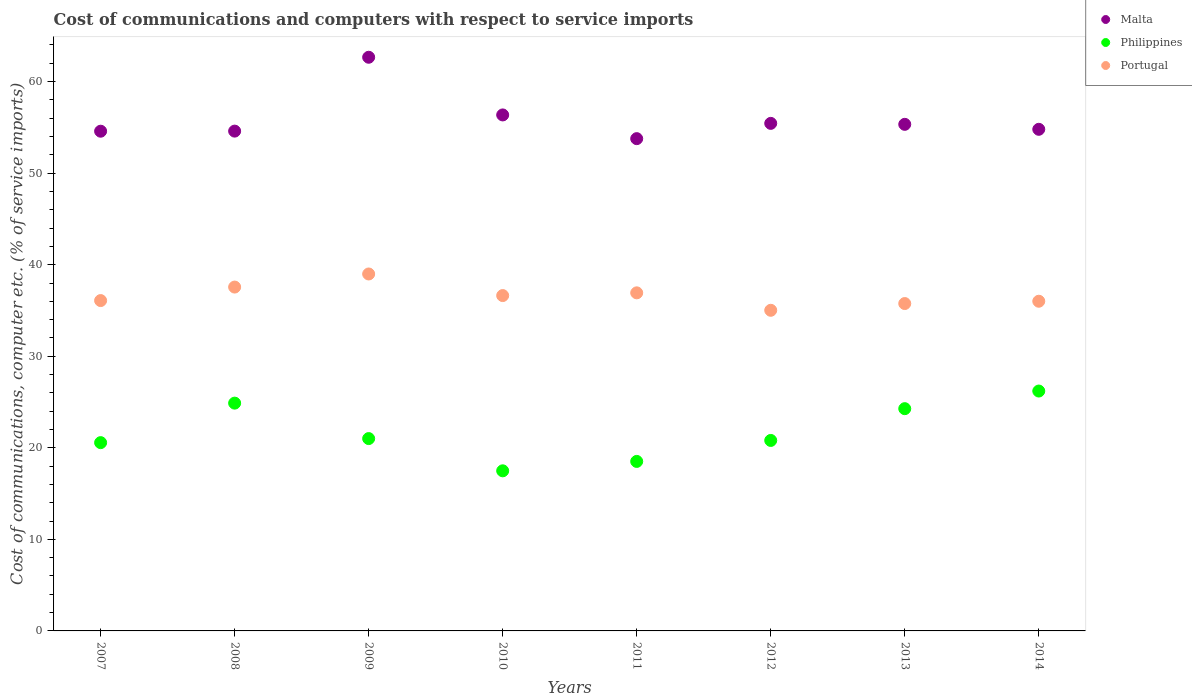What is the cost of communications and computers in Malta in 2011?
Ensure brevity in your answer.  53.77. Across all years, what is the maximum cost of communications and computers in Philippines?
Your answer should be compact. 26.2. Across all years, what is the minimum cost of communications and computers in Portugal?
Provide a short and direct response. 35.02. What is the total cost of communications and computers in Portugal in the graph?
Provide a succinct answer. 292.98. What is the difference between the cost of communications and computers in Malta in 2010 and that in 2013?
Give a very brief answer. 1.03. What is the difference between the cost of communications and computers in Philippines in 2008 and the cost of communications and computers in Malta in 2007?
Provide a succinct answer. -29.7. What is the average cost of communications and computers in Philippines per year?
Your answer should be very brief. 21.72. In the year 2007, what is the difference between the cost of communications and computers in Philippines and cost of communications and computers in Malta?
Offer a very short reply. -34.02. What is the ratio of the cost of communications and computers in Philippines in 2009 to that in 2014?
Keep it short and to the point. 0.8. What is the difference between the highest and the second highest cost of communications and computers in Philippines?
Keep it short and to the point. 1.32. What is the difference between the highest and the lowest cost of communications and computers in Philippines?
Your response must be concise. 8.71. In how many years, is the cost of communications and computers in Malta greater than the average cost of communications and computers in Malta taken over all years?
Your answer should be compact. 2. Is it the case that in every year, the sum of the cost of communications and computers in Philippines and cost of communications and computers in Malta  is greater than the cost of communications and computers in Portugal?
Provide a succinct answer. Yes. Does the cost of communications and computers in Portugal monotonically increase over the years?
Your answer should be very brief. No. Is the cost of communications and computers in Malta strictly greater than the cost of communications and computers in Portugal over the years?
Make the answer very short. Yes. How many years are there in the graph?
Offer a terse response. 8. Are the values on the major ticks of Y-axis written in scientific E-notation?
Give a very brief answer. No. Does the graph contain any zero values?
Give a very brief answer. No. Where does the legend appear in the graph?
Make the answer very short. Top right. What is the title of the graph?
Your response must be concise. Cost of communications and computers with respect to service imports. What is the label or title of the Y-axis?
Provide a succinct answer. Cost of communications, computer etc. (% of service imports). What is the Cost of communications, computer etc. (% of service imports) of Malta in 2007?
Offer a terse response. 54.58. What is the Cost of communications, computer etc. (% of service imports) in Philippines in 2007?
Your answer should be compact. 20.57. What is the Cost of communications, computer etc. (% of service imports) of Portugal in 2007?
Give a very brief answer. 36.08. What is the Cost of communications, computer etc. (% of service imports) of Malta in 2008?
Your answer should be compact. 54.59. What is the Cost of communications, computer etc. (% of service imports) in Philippines in 2008?
Provide a short and direct response. 24.88. What is the Cost of communications, computer etc. (% of service imports) in Portugal in 2008?
Keep it short and to the point. 37.56. What is the Cost of communications, computer etc. (% of service imports) in Malta in 2009?
Offer a very short reply. 62.66. What is the Cost of communications, computer etc. (% of service imports) in Philippines in 2009?
Make the answer very short. 21.01. What is the Cost of communications, computer etc. (% of service imports) of Portugal in 2009?
Your answer should be very brief. 38.99. What is the Cost of communications, computer etc. (% of service imports) in Malta in 2010?
Offer a very short reply. 56.36. What is the Cost of communications, computer etc. (% of service imports) in Philippines in 2010?
Give a very brief answer. 17.49. What is the Cost of communications, computer etc. (% of service imports) in Portugal in 2010?
Your answer should be compact. 36.63. What is the Cost of communications, computer etc. (% of service imports) in Malta in 2011?
Your response must be concise. 53.77. What is the Cost of communications, computer etc. (% of service imports) in Philippines in 2011?
Your response must be concise. 18.51. What is the Cost of communications, computer etc. (% of service imports) in Portugal in 2011?
Your answer should be compact. 36.93. What is the Cost of communications, computer etc. (% of service imports) in Malta in 2012?
Make the answer very short. 55.44. What is the Cost of communications, computer etc. (% of service imports) in Philippines in 2012?
Provide a succinct answer. 20.81. What is the Cost of communications, computer etc. (% of service imports) in Portugal in 2012?
Give a very brief answer. 35.02. What is the Cost of communications, computer etc. (% of service imports) of Malta in 2013?
Provide a succinct answer. 55.33. What is the Cost of communications, computer etc. (% of service imports) of Philippines in 2013?
Your answer should be very brief. 24.28. What is the Cost of communications, computer etc. (% of service imports) in Portugal in 2013?
Your answer should be very brief. 35.76. What is the Cost of communications, computer etc. (% of service imports) of Malta in 2014?
Your answer should be very brief. 54.79. What is the Cost of communications, computer etc. (% of service imports) in Philippines in 2014?
Your response must be concise. 26.2. What is the Cost of communications, computer etc. (% of service imports) in Portugal in 2014?
Ensure brevity in your answer.  36.01. Across all years, what is the maximum Cost of communications, computer etc. (% of service imports) in Malta?
Your answer should be very brief. 62.66. Across all years, what is the maximum Cost of communications, computer etc. (% of service imports) of Philippines?
Your response must be concise. 26.2. Across all years, what is the maximum Cost of communications, computer etc. (% of service imports) of Portugal?
Ensure brevity in your answer.  38.99. Across all years, what is the minimum Cost of communications, computer etc. (% of service imports) of Malta?
Keep it short and to the point. 53.77. Across all years, what is the minimum Cost of communications, computer etc. (% of service imports) in Philippines?
Offer a terse response. 17.49. Across all years, what is the minimum Cost of communications, computer etc. (% of service imports) in Portugal?
Offer a terse response. 35.02. What is the total Cost of communications, computer etc. (% of service imports) in Malta in the graph?
Your answer should be very brief. 447.53. What is the total Cost of communications, computer etc. (% of service imports) in Philippines in the graph?
Your response must be concise. 173.74. What is the total Cost of communications, computer etc. (% of service imports) of Portugal in the graph?
Provide a succinct answer. 292.98. What is the difference between the Cost of communications, computer etc. (% of service imports) of Malta in 2007 and that in 2008?
Make the answer very short. -0.01. What is the difference between the Cost of communications, computer etc. (% of service imports) in Philippines in 2007 and that in 2008?
Offer a terse response. -4.32. What is the difference between the Cost of communications, computer etc. (% of service imports) of Portugal in 2007 and that in 2008?
Keep it short and to the point. -1.48. What is the difference between the Cost of communications, computer etc. (% of service imports) of Malta in 2007 and that in 2009?
Your answer should be very brief. -8.08. What is the difference between the Cost of communications, computer etc. (% of service imports) in Philippines in 2007 and that in 2009?
Ensure brevity in your answer.  -0.44. What is the difference between the Cost of communications, computer etc. (% of service imports) in Portugal in 2007 and that in 2009?
Your response must be concise. -2.91. What is the difference between the Cost of communications, computer etc. (% of service imports) of Malta in 2007 and that in 2010?
Offer a very short reply. -1.78. What is the difference between the Cost of communications, computer etc. (% of service imports) in Philippines in 2007 and that in 2010?
Provide a short and direct response. 3.08. What is the difference between the Cost of communications, computer etc. (% of service imports) in Portugal in 2007 and that in 2010?
Your response must be concise. -0.55. What is the difference between the Cost of communications, computer etc. (% of service imports) in Malta in 2007 and that in 2011?
Keep it short and to the point. 0.81. What is the difference between the Cost of communications, computer etc. (% of service imports) of Philippines in 2007 and that in 2011?
Ensure brevity in your answer.  2.05. What is the difference between the Cost of communications, computer etc. (% of service imports) in Portugal in 2007 and that in 2011?
Your answer should be very brief. -0.84. What is the difference between the Cost of communications, computer etc. (% of service imports) in Malta in 2007 and that in 2012?
Offer a very short reply. -0.86. What is the difference between the Cost of communications, computer etc. (% of service imports) of Philippines in 2007 and that in 2012?
Offer a terse response. -0.24. What is the difference between the Cost of communications, computer etc. (% of service imports) of Portugal in 2007 and that in 2012?
Your response must be concise. 1.06. What is the difference between the Cost of communications, computer etc. (% of service imports) in Malta in 2007 and that in 2013?
Make the answer very short. -0.75. What is the difference between the Cost of communications, computer etc. (% of service imports) of Philippines in 2007 and that in 2013?
Your answer should be compact. -3.71. What is the difference between the Cost of communications, computer etc. (% of service imports) in Portugal in 2007 and that in 2013?
Give a very brief answer. 0.32. What is the difference between the Cost of communications, computer etc. (% of service imports) of Malta in 2007 and that in 2014?
Your answer should be very brief. -0.21. What is the difference between the Cost of communications, computer etc. (% of service imports) of Philippines in 2007 and that in 2014?
Your response must be concise. -5.64. What is the difference between the Cost of communications, computer etc. (% of service imports) of Portugal in 2007 and that in 2014?
Ensure brevity in your answer.  0.07. What is the difference between the Cost of communications, computer etc. (% of service imports) of Malta in 2008 and that in 2009?
Your answer should be very brief. -8.07. What is the difference between the Cost of communications, computer etc. (% of service imports) in Philippines in 2008 and that in 2009?
Your response must be concise. 3.87. What is the difference between the Cost of communications, computer etc. (% of service imports) in Portugal in 2008 and that in 2009?
Keep it short and to the point. -1.43. What is the difference between the Cost of communications, computer etc. (% of service imports) in Malta in 2008 and that in 2010?
Keep it short and to the point. -1.77. What is the difference between the Cost of communications, computer etc. (% of service imports) of Philippines in 2008 and that in 2010?
Offer a terse response. 7.39. What is the difference between the Cost of communications, computer etc. (% of service imports) in Portugal in 2008 and that in 2010?
Your response must be concise. 0.93. What is the difference between the Cost of communications, computer etc. (% of service imports) in Malta in 2008 and that in 2011?
Keep it short and to the point. 0.82. What is the difference between the Cost of communications, computer etc. (% of service imports) in Philippines in 2008 and that in 2011?
Provide a succinct answer. 6.37. What is the difference between the Cost of communications, computer etc. (% of service imports) in Portugal in 2008 and that in 2011?
Your answer should be compact. 0.63. What is the difference between the Cost of communications, computer etc. (% of service imports) of Malta in 2008 and that in 2012?
Your answer should be very brief. -0.85. What is the difference between the Cost of communications, computer etc. (% of service imports) in Philippines in 2008 and that in 2012?
Your answer should be compact. 4.08. What is the difference between the Cost of communications, computer etc. (% of service imports) in Portugal in 2008 and that in 2012?
Your response must be concise. 2.54. What is the difference between the Cost of communications, computer etc. (% of service imports) in Malta in 2008 and that in 2013?
Offer a terse response. -0.74. What is the difference between the Cost of communications, computer etc. (% of service imports) in Philippines in 2008 and that in 2013?
Provide a short and direct response. 0.6. What is the difference between the Cost of communications, computer etc. (% of service imports) of Portugal in 2008 and that in 2013?
Your answer should be compact. 1.8. What is the difference between the Cost of communications, computer etc. (% of service imports) of Malta in 2008 and that in 2014?
Provide a short and direct response. -0.2. What is the difference between the Cost of communications, computer etc. (% of service imports) in Philippines in 2008 and that in 2014?
Offer a very short reply. -1.32. What is the difference between the Cost of communications, computer etc. (% of service imports) in Portugal in 2008 and that in 2014?
Make the answer very short. 1.55. What is the difference between the Cost of communications, computer etc. (% of service imports) in Malta in 2009 and that in 2010?
Offer a very short reply. 6.3. What is the difference between the Cost of communications, computer etc. (% of service imports) of Philippines in 2009 and that in 2010?
Offer a very short reply. 3.52. What is the difference between the Cost of communications, computer etc. (% of service imports) in Portugal in 2009 and that in 2010?
Your answer should be compact. 2.36. What is the difference between the Cost of communications, computer etc. (% of service imports) of Malta in 2009 and that in 2011?
Your answer should be very brief. 8.89. What is the difference between the Cost of communications, computer etc. (% of service imports) of Philippines in 2009 and that in 2011?
Give a very brief answer. 2.49. What is the difference between the Cost of communications, computer etc. (% of service imports) in Portugal in 2009 and that in 2011?
Your response must be concise. 2.06. What is the difference between the Cost of communications, computer etc. (% of service imports) in Malta in 2009 and that in 2012?
Offer a terse response. 7.22. What is the difference between the Cost of communications, computer etc. (% of service imports) of Philippines in 2009 and that in 2012?
Provide a short and direct response. 0.2. What is the difference between the Cost of communications, computer etc. (% of service imports) in Portugal in 2009 and that in 2012?
Provide a succinct answer. 3.97. What is the difference between the Cost of communications, computer etc. (% of service imports) of Malta in 2009 and that in 2013?
Your response must be concise. 7.33. What is the difference between the Cost of communications, computer etc. (% of service imports) in Philippines in 2009 and that in 2013?
Provide a short and direct response. -3.27. What is the difference between the Cost of communications, computer etc. (% of service imports) of Portugal in 2009 and that in 2013?
Make the answer very short. 3.23. What is the difference between the Cost of communications, computer etc. (% of service imports) in Malta in 2009 and that in 2014?
Provide a succinct answer. 7.87. What is the difference between the Cost of communications, computer etc. (% of service imports) in Philippines in 2009 and that in 2014?
Your response must be concise. -5.19. What is the difference between the Cost of communications, computer etc. (% of service imports) of Portugal in 2009 and that in 2014?
Your answer should be very brief. 2.98. What is the difference between the Cost of communications, computer etc. (% of service imports) of Malta in 2010 and that in 2011?
Ensure brevity in your answer.  2.59. What is the difference between the Cost of communications, computer etc. (% of service imports) of Philippines in 2010 and that in 2011?
Offer a very short reply. -1.03. What is the difference between the Cost of communications, computer etc. (% of service imports) of Portugal in 2010 and that in 2011?
Your response must be concise. -0.3. What is the difference between the Cost of communications, computer etc. (% of service imports) in Malta in 2010 and that in 2012?
Make the answer very short. 0.92. What is the difference between the Cost of communications, computer etc. (% of service imports) of Philippines in 2010 and that in 2012?
Provide a short and direct response. -3.32. What is the difference between the Cost of communications, computer etc. (% of service imports) in Portugal in 2010 and that in 2012?
Provide a short and direct response. 1.61. What is the difference between the Cost of communications, computer etc. (% of service imports) in Malta in 2010 and that in 2013?
Offer a very short reply. 1.03. What is the difference between the Cost of communications, computer etc. (% of service imports) of Philippines in 2010 and that in 2013?
Make the answer very short. -6.79. What is the difference between the Cost of communications, computer etc. (% of service imports) of Portugal in 2010 and that in 2013?
Your answer should be compact. 0.87. What is the difference between the Cost of communications, computer etc. (% of service imports) of Malta in 2010 and that in 2014?
Give a very brief answer. 1.57. What is the difference between the Cost of communications, computer etc. (% of service imports) of Philippines in 2010 and that in 2014?
Your answer should be compact. -8.71. What is the difference between the Cost of communications, computer etc. (% of service imports) of Portugal in 2010 and that in 2014?
Your response must be concise. 0.62. What is the difference between the Cost of communications, computer etc. (% of service imports) of Malta in 2011 and that in 2012?
Offer a very short reply. -1.67. What is the difference between the Cost of communications, computer etc. (% of service imports) of Philippines in 2011 and that in 2012?
Your answer should be compact. -2.29. What is the difference between the Cost of communications, computer etc. (% of service imports) in Portugal in 2011 and that in 2012?
Keep it short and to the point. 1.91. What is the difference between the Cost of communications, computer etc. (% of service imports) of Malta in 2011 and that in 2013?
Your answer should be compact. -1.56. What is the difference between the Cost of communications, computer etc. (% of service imports) of Philippines in 2011 and that in 2013?
Give a very brief answer. -5.76. What is the difference between the Cost of communications, computer etc. (% of service imports) in Portugal in 2011 and that in 2013?
Provide a succinct answer. 1.17. What is the difference between the Cost of communications, computer etc. (% of service imports) of Malta in 2011 and that in 2014?
Your answer should be compact. -1.02. What is the difference between the Cost of communications, computer etc. (% of service imports) of Philippines in 2011 and that in 2014?
Your answer should be compact. -7.69. What is the difference between the Cost of communications, computer etc. (% of service imports) in Portugal in 2011 and that in 2014?
Your answer should be very brief. 0.92. What is the difference between the Cost of communications, computer etc. (% of service imports) of Malta in 2012 and that in 2013?
Provide a short and direct response. 0.11. What is the difference between the Cost of communications, computer etc. (% of service imports) of Philippines in 2012 and that in 2013?
Offer a terse response. -3.47. What is the difference between the Cost of communications, computer etc. (% of service imports) of Portugal in 2012 and that in 2013?
Ensure brevity in your answer.  -0.74. What is the difference between the Cost of communications, computer etc. (% of service imports) in Malta in 2012 and that in 2014?
Offer a very short reply. 0.65. What is the difference between the Cost of communications, computer etc. (% of service imports) of Philippines in 2012 and that in 2014?
Ensure brevity in your answer.  -5.4. What is the difference between the Cost of communications, computer etc. (% of service imports) of Portugal in 2012 and that in 2014?
Give a very brief answer. -0.99. What is the difference between the Cost of communications, computer etc. (% of service imports) of Malta in 2013 and that in 2014?
Your answer should be compact. 0.54. What is the difference between the Cost of communications, computer etc. (% of service imports) of Philippines in 2013 and that in 2014?
Ensure brevity in your answer.  -1.93. What is the difference between the Cost of communications, computer etc. (% of service imports) in Portugal in 2013 and that in 2014?
Provide a succinct answer. -0.25. What is the difference between the Cost of communications, computer etc. (% of service imports) of Malta in 2007 and the Cost of communications, computer etc. (% of service imports) of Philippines in 2008?
Your answer should be very brief. 29.7. What is the difference between the Cost of communications, computer etc. (% of service imports) of Malta in 2007 and the Cost of communications, computer etc. (% of service imports) of Portugal in 2008?
Your answer should be very brief. 17.02. What is the difference between the Cost of communications, computer etc. (% of service imports) in Philippines in 2007 and the Cost of communications, computer etc. (% of service imports) in Portugal in 2008?
Provide a succinct answer. -16.99. What is the difference between the Cost of communications, computer etc. (% of service imports) of Malta in 2007 and the Cost of communications, computer etc. (% of service imports) of Philippines in 2009?
Keep it short and to the point. 33.57. What is the difference between the Cost of communications, computer etc. (% of service imports) in Malta in 2007 and the Cost of communications, computer etc. (% of service imports) in Portugal in 2009?
Your response must be concise. 15.59. What is the difference between the Cost of communications, computer etc. (% of service imports) in Philippines in 2007 and the Cost of communications, computer etc. (% of service imports) in Portugal in 2009?
Provide a succinct answer. -18.42. What is the difference between the Cost of communications, computer etc. (% of service imports) of Malta in 2007 and the Cost of communications, computer etc. (% of service imports) of Philippines in 2010?
Provide a succinct answer. 37.1. What is the difference between the Cost of communications, computer etc. (% of service imports) in Malta in 2007 and the Cost of communications, computer etc. (% of service imports) in Portugal in 2010?
Offer a terse response. 17.95. What is the difference between the Cost of communications, computer etc. (% of service imports) of Philippines in 2007 and the Cost of communications, computer etc. (% of service imports) of Portugal in 2010?
Keep it short and to the point. -16.06. What is the difference between the Cost of communications, computer etc. (% of service imports) in Malta in 2007 and the Cost of communications, computer etc. (% of service imports) in Philippines in 2011?
Keep it short and to the point. 36.07. What is the difference between the Cost of communications, computer etc. (% of service imports) of Malta in 2007 and the Cost of communications, computer etc. (% of service imports) of Portugal in 2011?
Make the answer very short. 17.66. What is the difference between the Cost of communications, computer etc. (% of service imports) in Philippines in 2007 and the Cost of communications, computer etc. (% of service imports) in Portugal in 2011?
Offer a very short reply. -16.36. What is the difference between the Cost of communications, computer etc. (% of service imports) in Malta in 2007 and the Cost of communications, computer etc. (% of service imports) in Philippines in 2012?
Make the answer very short. 33.78. What is the difference between the Cost of communications, computer etc. (% of service imports) in Malta in 2007 and the Cost of communications, computer etc. (% of service imports) in Portugal in 2012?
Keep it short and to the point. 19.56. What is the difference between the Cost of communications, computer etc. (% of service imports) in Philippines in 2007 and the Cost of communications, computer etc. (% of service imports) in Portugal in 2012?
Make the answer very short. -14.46. What is the difference between the Cost of communications, computer etc. (% of service imports) in Malta in 2007 and the Cost of communications, computer etc. (% of service imports) in Philippines in 2013?
Your answer should be compact. 30.31. What is the difference between the Cost of communications, computer etc. (% of service imports) of Malta in 2007 and the Cost of communications, computer etc. (% of service imports) of Portugal in 2013?
Your answer should be compact. 18.82. What is the difference between the Cost of communications, computer etc. (% of service imports) in Philippines in 2007 and the Cost of communications, computer etc. (% of service imports) in Portugal in 2013?
Ensure brevity in your answer.  -15.19. What is the difference between the Cost of communications, computer etc. (% of service imports) in Malta in 2007 and the Cost of communications, computer etc. (% of service imports) in Philippines in 2014?
Provide a succinct answer. 28.38. What is the difference between the Cost of communications, computer etc. (% of service imports) in Malta in 2007 and the Cost of communications, computer etc. (% of service imports) in Portugal in 2014?
Offer a very short reply. 18.57. What is the difference between the Cost of communications, computer etc. (% of service imports) in Philippines in 2007 and the Cost of communications, computer etc. (% of service imports) in Portugal in 2014?
Keep it short and to the point. -15.45. What is the difference between the Cost of communications, computer etc. (% of service imports) in Malta in 2008 and the Cost of communications, computer etc. (% of service imports) in Philippines in 2009?
Offer a terse response. 33.58. What is the difference between the Cost of communications, computer etc. (% of service imports) of Malta in 2008 and the Cost of communications, computer etc. (% of service imports) of Portugal in 2009?
Your answer should be compact. 15.6. What is the difference between the Cost of communications, computer etc. (% of service imports) of Philippines in 2008 and the Cost of communications, computer etc. (% of service imports) of Portugal in 2009?
Provide a short and direct response. -14.11. What is the difference between the Cost of communications, computer etc. (% of service imports) in Malta in 2008 and the Cost of communications, computer etc. (% of service imports) in Philippines in 2010?
Make the answer very short. 37.11. What is the difference between the Cost of communications, computer etc. (% of service imports) of Malta in 2008 and the Cost of communications, computer etc. (% of service imports) of Portugal in 2010?
Your answer should be compact. 17.96. What is the difference between the Cost of communications, computer etc. (% of service imports) of Philippines in 2008 and the Cost of communications, computer etc. (% of service imports) of Portugal in 2010?
Make the answer very short. -11.75. What is the difference between the Cost of communications, computer etc. (% of service imports) in Malta in 2008 and the Cost of communications, computer etc. (% of service imports) in Philippines in 2011?
Give a very brief answer. 36.08. What is the difference between the Cost of communications, computer etc. (% of service imports) in Malta in 2008 and the Cost of communications, computer etc. (% of service imports) in Portugal in 2011?
Provide a short and direct response. 17.67. What is the difference between the Cost of communications, computer etc. (% of service imports) of Philippines in 2008 and the Cost of communications, computer etc. (% of service imports) of Portugal in 2011?
Give a very brief answer. -12.05. What is the difference between the Cost of communications, computer etc. (% of service imports) of Malta in 2008 and the Cost of communications, computer etc. (% of service imports) of Philippines in 2012?
Keep it short and to the point. 33.79. What is the difference between the Cost of communications, computer etc. (% of service imports) of Malta in 2008 and the Cost of communications, computer etc. (% of service imports) of Portugal in 2012?
Your answer should be compact. 19.57. What is the difference between the Cost of communications, computer etc. (% of service imports) of Philippines in 2008 and the Cost of communications, computer etc. (% of service imports) of Portugal in 2012?
Give a very brief answer. -10.14. What is the difference between the Cost of communications, computer etc. (% of service imports) in Malta in 2008 and the Cost of communications, computer etc. (% of service imports) in Philippines in 2013?
Make the answer very short. 30.32. What is the difference between the Cost of communications, computer etc. (% of service imports) in Malta in 2008 and the Cost of communications, computer etc. (% of service imports) in Portugal in 2013?
Your answer should be compact. 18.83. What is the difference between the Cost of communications, computer etc. (% of service imports) of Philippines in 2008 and the Cost of communications, computer etc. (% of service imports) of Portugal in 2013?
Ensure brevity in your answer.  -10.88. What is the difference between the Cost of communications, computer etc. (% of service imports) in Malta in 2008 and the Cost of communications, computer etc. (% of service imports) in Philippines in 2014?
Offer a very short reply. 28.39. What is the difference between the Cost of communications, computer etc. (% of service imports) in Malta in 2008 and the Cost of communications, computer etc. (% of service imports) in Portugal in 2014?
Offer a very short reply. 18.58. What is the difference between the Cost of communications, computer etc. (% of service imports) in Philippines in 2008 and the Cost of communications, computer etc. (% of service imports) in Portugal in 2014?
Your answer should be very brief. -11.13. What is the difference between the Cost of communications, computer etc. (% of service imports) in Malta in 2009 and the Cost of communications, computer etc. (% of service imports) in Philippines in 2010?
Provide a short and direct response. 45.17. What is the difference between the Cost of communications, computer etc. (% of service imports) in Malta in 2009 and the Cost of communications, computer etc. (% of service imports) in Portugal in 2010?
Offer a terse response. 26.03. What is the difference between the Cost of communications, computer etc. (% of service imports) in Philippines in 2009 and the Cost of communications, computer etc. (% of service imports) in Portugal in 2010?
Your response must be concise. -15.62. What is the difference between the Cost of communications, computer etc. (% of service imports) in Malta in 2009 and the Cost of communications, computer etc. (% of service imports) in Philippines in 2011?
Offer a very short reply. 44.15. What is the difference between the Cost of communications, computer etc. (% of service imports) in Malta in 2009 and the Cost of communications, computer etc. (% of service imports) in Portugal in 2011?
Provide a short and direct response. 25.73. What is the difference between the Cost of communications, computer etc. (% of service imports) of Philippines in 2009 and the Cost of communications, computer etc. (% of service imports) of Portugal in 2011?
Your answer should be very brief. -15.92. What is the difference between the Cost of communications, computer etc. (% of service imports) of Malta in 2009 and the Cost of communications, computer etc. (% of service imports) of Philippines in 2012?
Offer a terse response. 41.86. What is the difference between the Cost of communications, computer etc. (% of service imports) of Malta in 2009 and the Cost of communications, computer etc. (% of service imports) of Portugal in 2012?
Give a very brief answer. 27.64. What is the difference between the Cost of communications, computer etc. (% of service imports) of Philippines in 2009 and the Cost of communications, computer etc. (% of service imports) of Portugal in 2012?
Offer a terse response. -14.01. What is the difference between the Cost of communications, computer etc. (% of service imports) in Malta in 2009 and the Cost of communications, computer etc. (% of service imports) in Philippines in 2013?
Your answer should be very brief. 38.38. What is the difference between the Cost of communications, computer etc. (% of service imports) of Malta in 2009 and the Cost of communications, computer etc. (% of service imports) of Portugal in 2013?
Keep it short and to the point. 26.9. What is the difference between the Cost of communications, computer etc. (% of service imports) of Philippines in 2009 and the Cost of communications, computer etc. (% of service imports) of Portugal in 2013?
Give a very brief answer. -14.75. What is the difference between the Cost of communications, computer etc. (% of service imports) of Malta in 2009 and the Cost of communications, computer etc. (% of service imports) of Philippines in 2014?
Your answer should be very brief. 36.46. What is the difference between the Cost of communications, computer etc. (% of service imports) in Malta in 2009 and the Cost of communications, computer etc. (% of service imports) in Portugal in 2014?
Ensure brevity in your answer.  26.65. What is the difference between the Cost of communications, computer etc. (% of service imports) of Philippines in 2009 and the Cost of communications, computer etc. (% of service imports) of Portugal in 2014?
Make the answer very short. -15. What is the difference between the Cost of communications, computer etc. (% of service imports) in Malta in 2010 and the Cost of communications, computer etc. (% of service imports) in Philippines in 2011?
Provide a succinct answer. 37.85. What is the difference between the Cost of communications, computer etc. (% of service imports) in Malta in 2010 and the Cost of communications, computer etc. (% of service imports) in Portugal in 2011?
Offer a very short reply. 19.43. What is the difference between the Cost of communications, computer etc. (% of service imports) of Philippines in 2010 and the Cost of communications, computer etc. (% of service imports) of Portugal in 2011?
Your response must be concise. -19.44. What is the difference between the Cost of communications, computer etc. (% of service imports) of Malta in 2010 and the Cost of communications, computer etc. (% of service imports) of Philippines in 2012?
Your answer should be compact. 35.55. What is the difference between the Cost of communications, computer etc. (% of service imports) of Malta in 2010 and the Cost of communications, computer etc. (% of service imports) of Portugal in 2012?
Provide a succinct answer. 21.34. What is the difference between the Cost of communications, computer etc. (% of service imports) of Philippines in 2010 and the Cost of communications, computer etc. (% of service imports) of Portugal in 2012?
Provide a short and direct response. -17.53. What is the difference between the Cost of communications, computer etc. (% of service imports) in Malta in 2010 and the Cost of communications, computer etc. (% of service imports) in Philippines in 2013?
Ensure brevity in your answer.  32.08. What is the difference between the Cost of communications, computer etc. (% of service imports) of Malta in 2010 and the Cost of communications, computer etc. (% of service imports) of Portugal in 2013?
Give a very brief answer. 20.6. What is the difference between the Cost of communications, computer etc. (% of service imports) in Philippines in 2010 and the Cost of communications, computer etc. (% of service imports) in Portugal in 2013?
Your response must be concise. -18.27. What is the difference between the Cost of communications, computer etc. (% of service imports) of Malta in 2010 and the Cost of communications, computer etc. (% of service imports) of Philippines in 2014?
Provide a short and direct response. 30.16. What is the difference between the Cost of communications, computer etc. (% of service imports) of Malta in 2010 and the Cost of communications, computer etc. (% of service imports) of Portugal in 2014?
Your response must be concise. 20.35. What is the difference between the Cost of communications, computer etc. (% of service imports) of Philippines in 2010 and the Cost of communications, computer etc. (% of service imports) of Portugal in 2014?
Provide a succinct answer. -18.52. What is the difference between the Cost of communications, computer etc. (% of service imports) of Malta in 2011 and the Cost of communications, computer etc. (% of service imports) of Philippines in 2012?
Make the answer very short. 32.96. What is the difference between the Cost of communications, computer etc. (% of service imports) in Malta in 2011 and the Cost of communications, computer etc. (% of service imports) in Portugal in 2012?
Offer a terse response. 18.75. What is the difference between the Cost of communications, computer etc. (% of service imports) in Philippines in 2011 and the Cost of communications, computer etc. (% of service imports) in Portugal in 2012?
Your response must be concise. -16.51. What is the difference between the Cost of communications, computer etc. (% of service imports) of Malta in 2011 and the Cost of communications, computer etc. (% of service imports) of Philippines in 2013?
Offer a terse response. 29.49. What is the difference between the Cost of communications, computer etc. (% of service imports) in Malta in 2011 and the Cost of communications, computer etc. (% of service imports) in Portugal in 2013?
Provide a succinct answer. 18.01. What is the difference between the Cost of communications, computer etc. (% of service imports) of Philippines in 2011 and the Cost of communications, computer etc. (% of service imports) of Portugal in 2013?
Offer a terse response. -17.24. What is the difference between the Cost of communications, computer etc. (% of service imports) of Malta in 2011 and the Cost of communications, computer etc. (% of service imports) of Philippines in 2014?
Keep it short and to the point. 27.57. What is the difference between the Cost of communications, computer etc. (% of service imports) of Malta in 2011 and the Cost of communications, computer etc. (% of service imports) of Portugal in 2014?
Ensure brevity in your answer.  17.76. What is the difference between the Cost of communications, computer etc. (% of service imports) of Philippines in 2011 and the Cost of communications, computer etc. (% of service imports) of Portugal in 2014?
Ensure brevity in your answer.  -17.5. What is the difference between the Cost of communications, computer etc. (% of service imports) in Malta in 2012 and the Cost of communications, computer etc. (% of service imports) in Philippines in 2013?
Offer a terse response. 31.16. What is the difference between the Cost of communications, computer etc. (% of service imports) of Malta in 2012 and the Cost of communications, computer etc. (% of service imports) of Portugal in 2013?
Offer a terse response. 19.68. What is the difference between the Cost of communications, computer etc. (% of service imports) of Philippines in 2012 and the Cost of communications, computer etc. (% of service imports) of Portugal in 2013?
Keep it short and to the point. -14.95. What is the difference between the Cost of communications, computer etc. (% of service imports) of Malta in 2012 and the Cost of communications, computer etc. (% of service imports) of Philippines in 2014?
Offer a very short reply. 29.24. What is the difference between the Cost of communications, computer etc. (% of service imports) in Malta in 2012 and the Cost of communications, computer etc. (% of service imports) in Portugal in 2014?
Keep it short and to the point. 19.43. What is the difference between the Cost of communications, computer etc. (% of service imports) of Philippines in 2012 and the Cost of communications, computer etc. (% of service imports) of Portugal in 2014?
Offer a very short reply. -15.21. What is the difference between the Cost of communications, computer etc. (% of service imports) in Malta in 2013 and the Cost of communications, computer etc. (% of service imports) in Philippines in 2014?
Your response must be concise. 29.13. What is the difference between the Cost of communications, computer etc. (% of service imports) of Malta in 2013 and the Cost of communications, computer etc. (% of service imports) of Portugal in 2014?
Give a very brief answer. 19.32. What is the difference between the Cost of communications, computer etc. (% of service imports) of Philippines in 2013 and the Cost of communications, computer etc. (% of service imports) of Portugal in 2014?
Keep it short and to the point. -11.73. What is the average Cost of communications, computer etc. (% of service imports) in Malta per year?
Give a very brief answer. 55.94. What is the average Cost of communications, computer etc. (% of service imports) in Philippines per year?
Ensure brevity in your answer.  21.72. What is the average Cost of communications, computer etc. (% of service imports) in Portugal per year?
Give a very brief answer. 36.62. In the year 2007, what is the difference between the Cost of communications, computer etc. (% of service imports) of Malta and Cost of communications, computer etc. (% of service imports) of Philippines?
Provide a succinct answer. 34.02. In the year 2007, what is the difference between the Cost of communications, computer etc. (% of service imports) in Malta and Cost of communications, computer etc. (% of service imports) in Portugal?
Ensure brevity in your answer.  18.5. In the year 2007, what is the difference between the Cost of communications, computer etc. (% of service imports) in Philippines and Cost of communications, computer etc. (% of service imports) in Portugal?
Keep it short and to the point. -15.52. In the year 2008, what is the difference between the Cost of communications, computer etc. (% of service imports) in Malta and Cost of communications, computer etc. (% of service imports) in Philippines?
Offer a terse response. 29.71. In the year 2008, what is the difference between the Cost of communications, computer etc. (% of service imports) of Malta and Cost of communications, computer etc. (% of service imports) of Portugal?
Provide a succinct answer. 17.03. In the year 2008, what is the difference between the Cost of communications, computer etc. (% of service imports) of Philippines and Cost of communications, computer etc. (% of service imports) of Portugal?
Offer a very short reply. -12.68. In the year 2009, what is the difference between the Cost of communications, computer etc. (% of service imports) in Malta and Cost of communications, computer etc. (% of service imports) in Philippines?
Make the answer very short. 41.65. In the year 2009, what is the difference between the Cost of communications, computer etc. (% of service imports) in Malta and Cost of communications, computer etc. (% of service imports) in Portugal?
Provide a short and direct response. 23.67. In the year 2009, what is the difference between the Cost of communications, computer etc. (% of service imports) of Philippines and Cost of communications, computer etc. (% of service imports) of Portugal?
Offer a very short reply. -17.98. In the year 2010, what is the difference between the Cost of communications, computer etc. (% of service imports) in Malta and Cost of communications, computer etc. (% of service imports) in Philippines?
Offer a very short reply. 38.87. In the year 2010, what is the difference between the Cost of communications, computer etc. (% of service imports) in Malta and Cost of communications, computer etc. (% of service imports) in Portugal?
Your response must be concise. 19.73. In the year 2010, what is the difference between the Cost of communications, computer etc. (% of service imports) in Philippines and Cost of communications, computer etc. (% of service imports) in Portugal?
Offer a very short reply. -19.14. In the year 2011, what is the difference between the Cost of communications, computer etc. (% of service imports) in Malta and Cost of communications, computer etc. (% of service imports) in Philippines?
Your answer should be compact. 35.26. In the year 2011, what is the difference between the Cost of communications, computer etc. (% of service imports) in Malta and Cost of communications, computer etc. (% of service imports) in Portugal?
Provide a short and direct response. 16.84. In the year 2011, what is the difference between the Cost of communications, computer etc. (% of service imports) in Philippines and Cost of communications, computer etc. (% of service imports) in Portugal?
Your response must be concise. -18.41. In the year 2012, what is the difference between the Cost of communications, computer etc. (% of service imports) in Malta and Cost of communications, computer etc. (% of service imports) in Philippines?
Provide a short and direct response. 34.63. In the year 2012, what is the difference between the Cost of communications, computer etc. (% of service imports) of Malta and Cost of communications, computer etc. (% of service imports) of Portugal?
Your answer should be compact. 20.42. In the year 2012, what is the difference between the Cost of communications, computer etc. (% of service imports) of Philippines and Cost of communications, computer etc. (% of service imports) of Portugal?
Give a very brief answer. -14.22. In the year 2013, what is the difference between the Cost of communications, computer etc. (% of service imports) in Malta and Cost of communications, computer etc. (% of service imports) in Philippines?
Offer a very short reply. 31.06. In the year 2013, what is the difference between the Cost of communications, computer etc. (% of service imports) of Malta and Cost of communications, computer etc. (% of service imports) of Portugal?
Ensure brevity in your answer.  19.57. In the year 2013, what is the difference between the Cost of communications, computer etc. (% of service imports) in Philippines and Cost of communications, computer etc. (% of service imports) in Portugal?
Provide a succinct answer. -11.48. In the year 2014, what is the difference between the Cost of communications, computer etc. (% of service imports) of Malta and Cost of communications, computer etc. (% of service imports) of Philippines?
Your answer should be compact. 28.59. In the year 2014, what is the difference between the Cost of communications, computer etc. (% of service imports) in Malta and Cost of communications, computer etc. (% of service imports) in Portugal?
Give a very brief answer. 18.78. In the year 2014, what is the difference between the Cost of communications, computer etc. (% of service imports) in Philippines and Cost of communications, computer etc. (% of service imports) in Portugal?
Offer a very short reply. -9.81. What is the ratio of the Cost of communications, computer etc. (% of service imports) of Philippines in 2007 to that in 2008?
Offer a terse response. 0.83. What is the ratio of the Cost of communications, computer etc. (% of service imports) in Portugal in 2007 to that in 2008?
Offer a very short reply. 0.96. What is the ratio of the Cost of communications, computer etc. (% of service imports) in Malta in 2007 to that in 2009?
Make the answer very short. 0.87. What is the ratio of the Cost of communications, computer etc. (% of service imports) in Philippines in 2007 to that in 2009?
Offer a very short reply. 0.98. What is the ratio of the Cost of communications, computer etc. (% of service imports) of Portugal in 2007 to that in 2009?
Offer a very short reply. 0.93. What is the ratio of the Cost of communications, computer etc. (% of service imports) in Malta in 2007 to that in 2010?
Make the answer very short. 0.97. What is the ratio of the Cost of communications, computer etc. (% of service imports) in Philippines in 2007 to that in 2010?
Offer a very short reply. 1.18. What is the ratio of the Cost of communications, computer etc. (% of service imports) in Portugal in 2007 to that in 2010?
Your answer should be compact. 0.99. What is the ratio of the Cost of communications, computer etc. (% of service imports) in Malta in 2007 to that in 2011?
Ensure brevity in your answer.  1.02. What is the ratio of the Cost of communications, computer etc. (% of service imports) of Philippines in 2007 to that in 2011?
Provide a succinct answer. 1.11. What is the ratio of the Cost of communications, computer etc. (% of service imports) of Portugal in 2007 to that in 2011?
Make the answer very short. 0.98. What is the ratio of the Cost of communications, computer etc. (% of service imports) in Malta in 2007 to that in 2012?
Provide a short and direct response. 0.98. What is the ratio of the Cost of communications, computer etc. (% of service imports) of Philippines in 2007 to that in 2012?
Your answer should be compact. 0.99. What is the ratio of the Cost of communications, computer etc. (% of service imports) of Portugal in 2007 to that in 2012?
Keep it short and to the point. 1.03. What is the ratio of the Cost of communications, computer etc. (% of service imports) in Malta in 2007 to that in 2013?
Offer a terse response. 0.99. What is the ratio of the Cost of communications, computer etc. (% of service imports) of Philippines in 2007 to that in 2013?
Keep it short and to the point. 0.85. What is the ratio of the Cost of communications, computer etc. (% of service imports) in Portugal in 2007 to that in 2013?
Provide a short and direct response. 1.01. What is the ratio of the Cost of communications, computer etc. (% of service imports) in Philippines in 2007 to that in 2014?
Keep it short and to the point. 0.78. What is the ratio of the Cost of communications, computer etc. (% of service imports) in Portugal in 2007 to that in 2014?
Keep it short and to the point. 1. What is the ratio of the Cost of communications, computer etc. (% of service imports) of Malta in 2008 to that in 2009?
Keep it short and to the point. 0.87. What is the ratio of the Cost of communications, computer etc. (% of service imports) in Philippines in 2008 to that in 2009?
Offer a terse response. 1.18. What is the ratio of the Cost of communications, computer etc. (% of service imports) in Portugal in 2008 to that in 2009?
Give a very brief answer. 0.96. What is the ratio of the Cost of communications, computer etc. (% of service imports) in Malta in 2008 to that in 2010?
Offer a terse response. 0.97. What is the ratio of the Cost of communications, computer etc. (% of service imports) in Philippines in 2008 to that in 2010?
Your answer should be compact. 1.42. What is the ratio of the Cost of communications, computer etc. (% of service imports) of Portugal in 2008 to that in 2010?
Make the answer very short. 1.03. What is the ratio of the Cost of communications, computer etc. (% of service imports) of Malta in 2008 to that in 2011?
Provide a short and direct response. 1.02. What is the ratio of the Cost of communications, computer etc. (% of service imports) in Philippines in 2008 to that in 2011?
Provide a succinct answer. 1.34. What is the ratio of the Cost of communications, computer etc. (% of service imports) in Portugal in 2008 to that in 2011?
Keep it short and to the point. 1.02. What is the ratio of the Cost of communications, computer etc. (% of service imports) of Philippines in 2008 to that in 2012?
Ensure brevity in your answer.  1.2. What is the ratio of the Cost of communications, computer etc. (% of service imports) of Portugal in 2008 to that in 2012?
Provide a succinct answer. 1.07. What is the ratio of the Cost of communications, computer etc. (% of service imports) in Malta in 2008 to that in 2013?
Provide a succinct answer. 0.99. What is the ratio of the Cost of communications, computer etc. (% of service imports) in Philippines in 2008 to that in 2013?
Give a very brief answer. 1.02. What is the ratio of the Cost of communications, computer etc. (% of service imports) in Portugal in 2008 to that in 2013?
Give a very brief answer. 1.05. What is the ratio of the Cost of communications, computer etc. (% of service imports) in Malta in 2008 to that in 2014?
Ensure brevity in your answer.  1. What is the ratio of the Cost of communications, computer etc. (% of service imports) of Philippines in 2008 to that in 2014?
Keep it short and to the point. 0.95. What is the ratio of the Cost of communications, computer etc. (% of service imports) of Portugal in 2008 to that in 2014?
Give a very brief answer. 1.04. What is the ratio of the Cost of communications, computer etc. (% of service imports) of Malta in 2009 to that in 2010?
Make the answer very short. 1.11. What is the ratio of the Cost of communications, computer etc. (% of service imports) of Philippines in 2009 to that in 2010?
Give a very brief answer. 1.2. What is the ratio of the Cost of communications, computer etc. (% of service imports) in Portugal in 2009 to that in 2010?
Your answer should be very brief. 1.06. What is the ratio of the Cost of communications, computer etc. (% of service imports) in Malta in 2009 to that in 2011?
Offer a very short reply. 1.17. What is the ratio of the Cost of communications, computer etc. (% of service imports) in Philippines in 2009 to that in 2011?
Offer a very short reply. 1.13. What is the ratio of the Cost of communications, computer etc. (% of service imports) of Portugal in 2009 to that in 2011?
Give a very brief answer. 1.06. What is the ratio of the Cost of communications, computer etc. (% of service imports) of Malta in 2009 to that in 2012?
Your answer should be very brief. 1.13. What is the ratio of the Cost of communications, computer etc. (% of service imports) in Philippines in 2009 to that in 2012?
Your answer should be very brief. 1.01. What is the ratio of the Cost of communications, computer etc. (% of service imports) of Portugal in 2009 to that in 2012?
Give a very brief answer. 1.11. What is the ratio of the Cost of communications, computer etc. (% of service imports) of Malta in 2009 to that in 2013?
Keep it short and to the point. 1.13. What is the ratio of the Cost of communications, computer etc. (% of service imports) in Philippines in 2009 to that in 2013?
Provide a succinct answer. 0.87. What is the ratio of the Cost of communications, computer etc. (% of service imports) of Portugal in 2009 to that in 2013?
Your answer should be very brief. 1.09. What is the ratio of the Cost of communications, computer etc. (% of service imports) of Malta in 2009 to that in 2014?
Provide a short and direct response. 1.14. What is the ratio of the Cost of communications, computer etc. (% of service imports) in Philippines in 2009 to that in 2014?
Make the answer very short. 0.8. What is the ratio of the Cost of communications, computer etc. (% of service imports) in Portugal in 2009 to that in 2014?
Give a very brief answer. 1.08. What is the ratio of the Cost of communications, computer etc. (% of service imports) in Malta in 2010 to that in 2011?
Your answer should be compact. 1.05. What is the ratio of the Cost of communications, computer etc. (% of service imports) of Philippines in 2010 to that in 2011?
Offer a terse response. 0.94. What is the ratio of the Cost of communications, computer etc. (% of service imports) of Portugal in 2010 to that in 2011?
Offer a very short reply. 0.99. What is the ratio of the Cost of communications, computer etc. (% of service imports) in Malta in 2010 to that in 2012?
Provide a short and direct response. 1.02. What is the ratio of the Cost of communications, computer etc. (% of service imports) of Philippines in 2010 to that in 2012?
Keep it short and to the point. 0.84. What is the ratio of the Cost of communications, computer etc. (% of service imports) in Portugal in 2010 to that in 2012?
Your answer should be very brief. 1.05. What is the ratio of the Cost of communications, computer etc. (% of service imports) in Malta in 2010 to that in 2013?
Keep it short and to the point. 1.02. What is the ratio of the Cost of communications, computer etc. (% of service imports) in Philippines in 2010 to that in 2013?
Your response must be concise. 0.72. What is the ratio of the Cost of communications, computer etc. (% of service imports) of Portugal in 2010 to that in 2013?
Your response must be concise. 1.02. What is the ratio of the Cost of communications, computer etc. (% of service imports) of Malta in 2010 to that in 2014?
Offer a very short reply. 1.03. What is the ratio of the Cost of communications, computer etc. (% of service imports) of Philippines in 2010 to that in 2014?
Keep it short and to the point. 0.67. What is the ratio of the Cost of communications, computer etc. (% of service imports) in Portugal in 2010 to that in 2014?
Offer a very short reply. 1.02. What is the ratio of the Cost of communications, computer etc. (% of service imports) of Malta in 2011 to that in 2012?
Give a very brief answer. 0.97. What is the ratio of the Cost of communications, computer etc. (% of service imports) of Philippines in 2011 to that in 2012?
Offer a terse response. 0.89. What is the ratio of the Cost of communications, computer etc. (% of service imports) of Portugal in 2011 to that in 2012?
Provide a succinct answer. 1.05. What is the ratio of the Cost of communications, computer etc. (% of service imports) of Malta in 2011 to that in 2013?
Your answer should be very brief. 0.97. What is the ratio of the Cost of communications, computer etc. (% of service imports) in Philippines in 2011 to that in 2013?
Your answer should be compact. 0.76. What is the ratio of the Cost of communications, computer etc. (% of service imports) in Portugal in 2011 to that in 2013?
Your answer should be compact. 1.03. What is the ratio of the Cost of communications, computer etc. (% of service imports) in Malta in 2011 to that in 2014?
Make the answer very short. 0.98. What is the ratio of the Cost of communications, computer etc. (% of service imports) of Philippines in 2011 to that in 2014?
Provide a short and direct response. 0.71. What is the ratio of the Cost of communications, computer etc. (% of service imports) of Portugal in 2011 to that in 2014?
Your response must be concise. 1.03. What is the ratio of the Cost of communications, computer etc. (% of service imports) of Philippines in 2012 to that in 2013?
Your answer should be very brief. 0.86. What is the ratio of the Cost of communications, computer etc. (% of service imports) of Portugal in 2012 to that in 2013?
Provide a short and direct response. 0.98. What is the ratio of the Cost of communications, computer etc. (% of service imports) in Malta in 2012 to that in 2014?
Provide a succinct answer. 1.01. What is the ratio of the Cost of communications, computer etc. (% of service imports) of Philippines in 2012 to that in 2014?
Give a very brief answer. 0.79. What is the ratio of the Cost of communications, computer etc. (% of service imports) in Portugal in 2012 to that in 2014?
Provide a short and direct response. 0.97. What is the ratio of the Cost of communications, computer etc. (% of service imports) of Malta in 2013 to that in 2014?
Make the answer very short. 1.01. What is the ratio of the Cost of communications, computer etc. (% of service imports) in Philippines in 2013 to that in 2014?
Ensure brevity in your answer.  0.93. What is the difference between the highest and the second highest Cost of communications, computer etc. (% of service imports) of Malta?
Keep it short and to the point. 6.3. What is the difference between the highest and the second highest Cost of communications, computer etc. (% of service imports) of Philippines?
Offer a very short reply. 1.32. What is the difference between the highest and the second highest Cost of communications, computer etc. (% of service imports) of Portugal?
Make the answer very short. 1.43. What is the difference between the highest and the lowest Cost of communications, computer etc. (% of service imports) in Malta?
Ensure brevity in your answer.  8.89. What is the difference between the highest and the lowest Cost of communications, computer etc. (% of service imports) in Philippines?
Make the answer very short. 8.71. What is the difference between the highest and the lowest Cost of communications, computer etc. (% of service imports) of Portugal?
Your response must be concise. 3.97. 